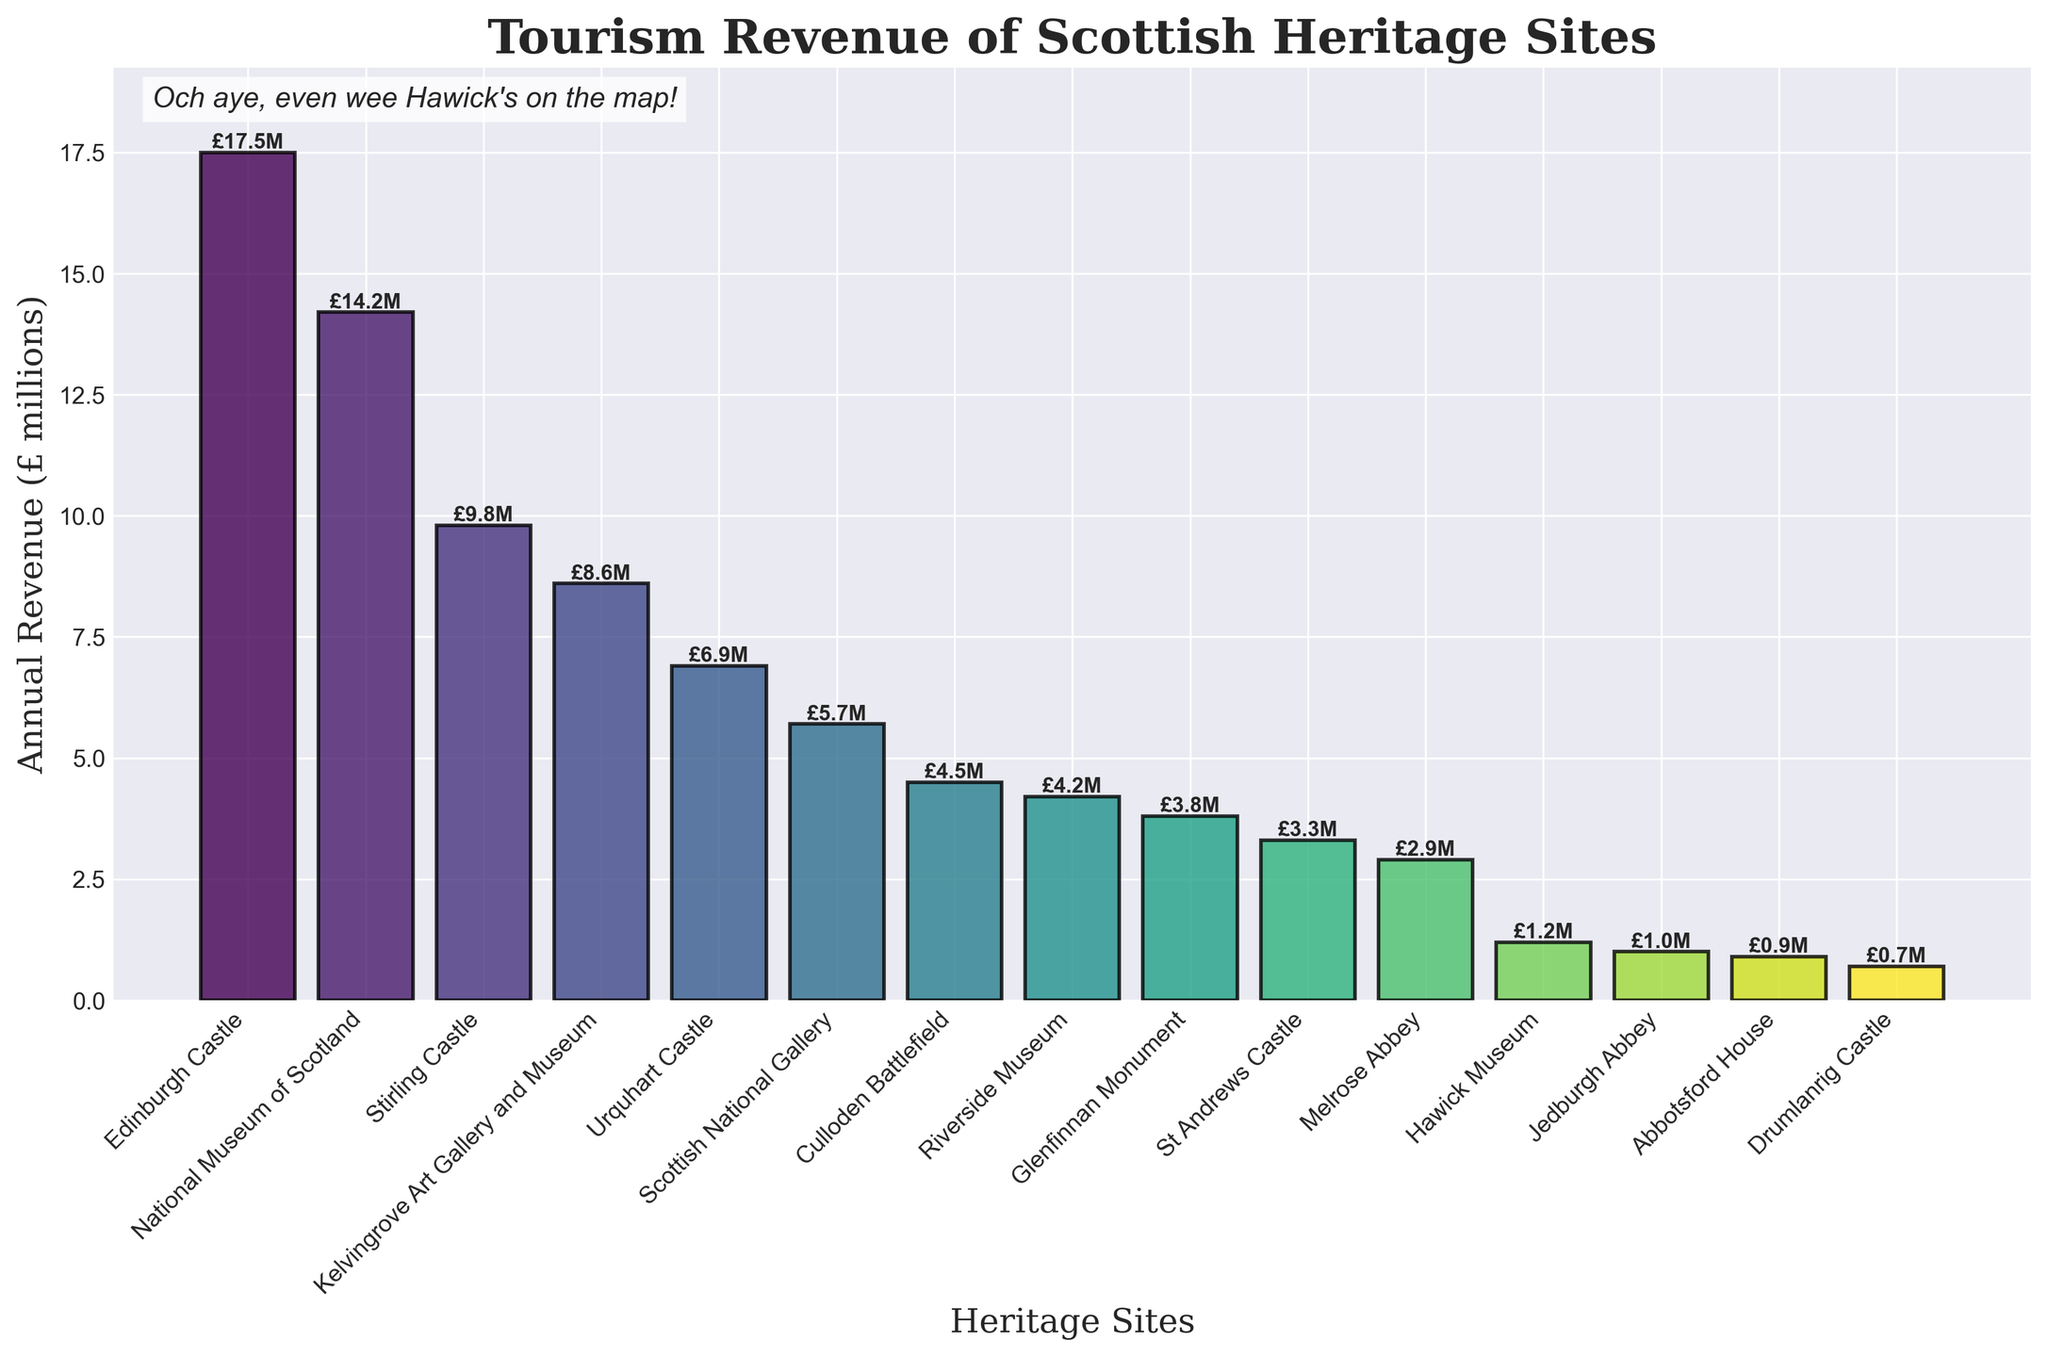Which heritage site generated the highest tourism revenue? From the figure, find the bar with the highest height. Edinburgh Castle shows the highest revenue at £17.5 million.
Answer: Edinburgh Castle How much more revenue did Edinburgh Castle generate compared to Urquhart Castle? Subtract the revenue of Urquhart Castle (£6.9 million) from Edinburgh Castle (£17.5 million). The difference is £17.5 - £6.9 = £10.6 million.
Answer: £10.6 million Which site generated the lowest tourism revenue? Locate the shortest bar in the figure. Abbotsford House generated the lowest revenue at £0.7 million.
Answer: Abbotsford House Which castle generated more revenue: Stirling Castle or St Andrews Castle, and by how much? Compare the heights of the bars for Stirling Castle (£9.8 million) and St Andrews Castle (£3.3 million). Stirling Castle generated £9.8 - £3.3 = £6.5 million more.
Answer: Stirling Castle by £6.5 million What is the total revenue generated by museums in the figure? Add the revenues of National Museum of Scotland (£14.2 million), Kelvingrove Art Gallery and Museum (£8.6 million), Scottish National Gallery (£5.7 million), Riverside Museum (£4.2 million), and Hawick Museum (£1.2 million). The total is 14.2 + 8.6 + 5.7 + 4.2 + 1.2 = £33.9 million.
Answer: £33.9 million How many heritage sites generated more than £10 million in revenue? Identify the bars that surpass the £10 million mark. Edinburgh Castle and National Museum of Scotland. There are 2 sites.
Answer: 2 What is the combined revenue of the top three revenue-generating sites? Add the revenues of Edinburgh Castle (£17.5 million), National Museum of Scotland (£14.2 million), and Stirling Castle (£9.8 million). The total is 17.5 + 14.2 + 9.8 = £41.5 million.
Answer: £41.5 million Is the average revenue generated by the listed sites above or below £5 million, and what is the average? Sum the revenues of all sites: 17.5 + 14.2 + 9.8 + 8.6 + 6.9 + 5.7 + 4.5 + 4.2 + 3.8 + 3.3 + 2.9 + 1.2 + 1.0 + 0.9 + 0.7 = £85.2 million. Divide by the number of sites (15). The average is 85.2 / 15 = £5.68 million. Since £5.68 million is above £5 million, the average revenue is above £5 million.
Answer: Above, £5.68 million What percentage of the total revenue was generated by the top two sites? Find the revenue of the top two sites (Edinburgh Castle and National Museum of Scotland) £17.5 million + £14.2 million = £31.7 million. Total revenue is £85.2 million. Calculate the percentage: (31.7 / 85.2) * 100 ≈ 37.21%.
Answer: 37.21% 